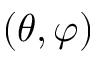Convert formula to latex. <formula><loc_0><loc_0><loc_500><loc_500>( \theta , \varphi )</formula> 